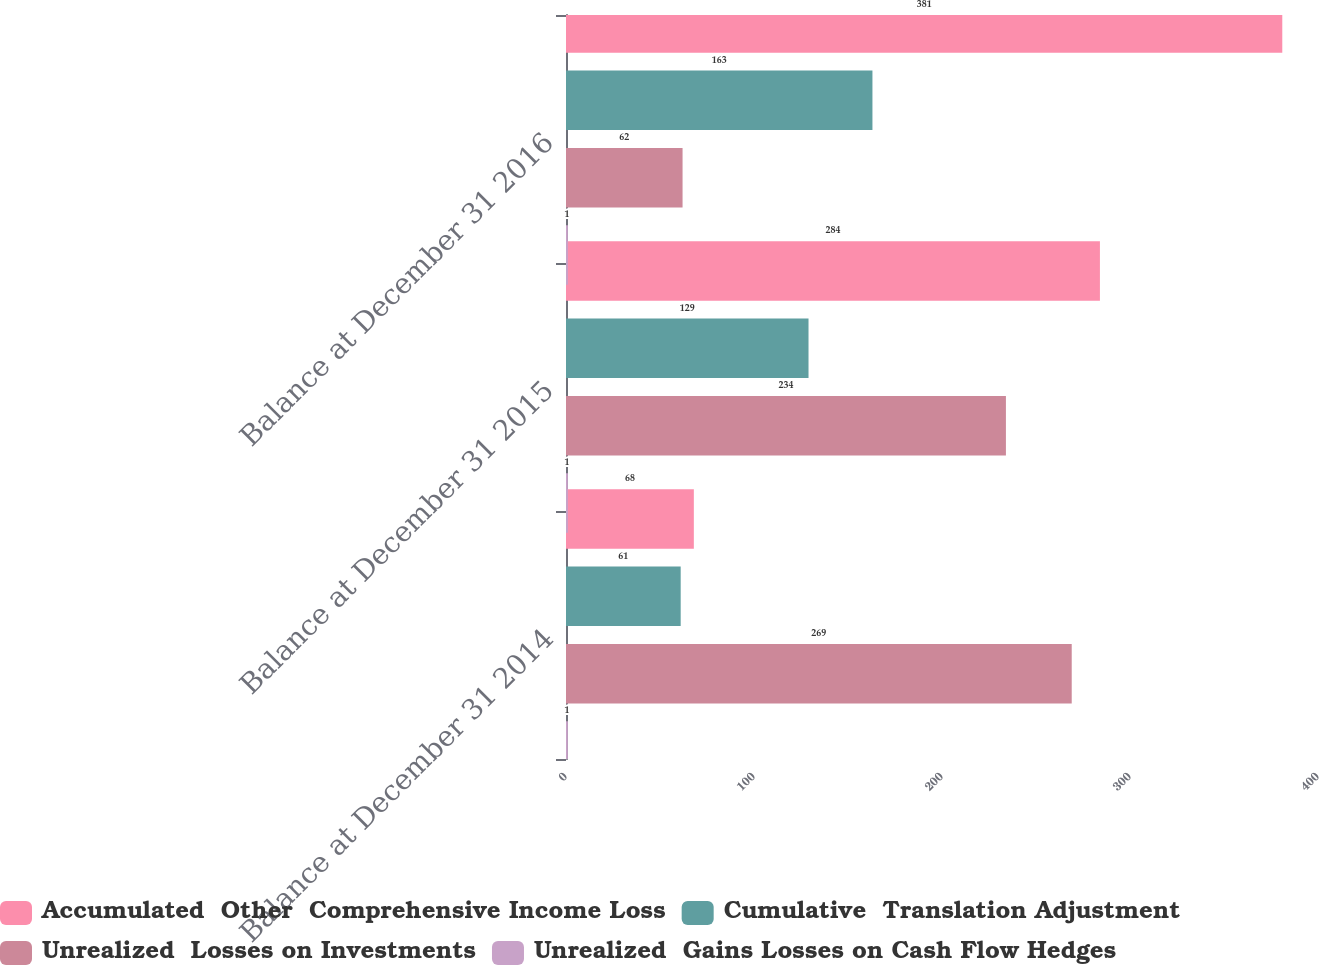Convert chart. <chart><loc_0><loc_0><loc_500><loc_500><stacked_bar_chart><ecel><fcel>Balance at December 31 2014<fcel>Balance at December 31 2015<fcel>Balance at December 31 2016<nl><fcel>Accumulated  Other  Comprehensive Income Loss<fcel>68<fcel>284<fcel>381<nl><fcel>Cumulative  Translation Adjustment<fcel>61<fcel>129<fcel>163<nl><fcel>Unrealized  Losses on Investments<fcel>269<fcel>234<fcel>62<nl><fcel>Unrealized  Gains Losses on Cash Flow Hedges<fcel>1<fcel>1<fcel>1<nl></chart> 